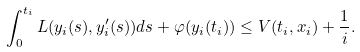Convert formula to latex. <formula><loc_0><loc_0><loc_500><loc_500>\int _ { 0 } ^ { t _ { i } } L ( y _ { i } ( s ) , y ^ { \prime } _ { i } ( s ) ) d s + \varphi ( y _ { i } ( t _ { i } ) ) \leq V ( t _ { i } , x _ { i } ) + \frac { 1 } { i } .</formula> 